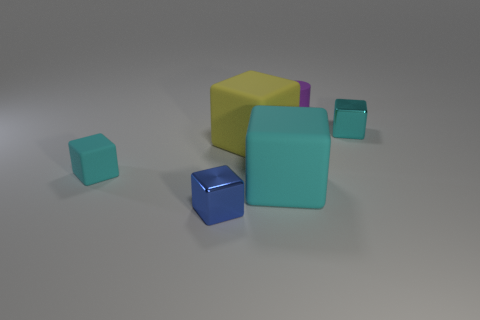Subtract all blue spheres. How many cyan blocks are left? 3 Subtract all small cyan cubes. How many cubes are left? 3 Subtract all blue blocks. How many blocks are left? 4 Add 2 tiny cyan matte cubes. How many objects exist? 8 Subtract all brown cubes. Subtract all purple balls. How many cubes are left? 5 Subtract all blocks. How many objects are left? 1 Subtract 0 blue spheres. How many objects are left? 6 Subtract all tiny purple matte things. Subtract all cyan metallic things. How many objects are left? 4 Add 4 tiny blue objects. How many tiny blue objects are left? 5 Add 4 big cyan matte things. How many big cyan matte things exist? 5 